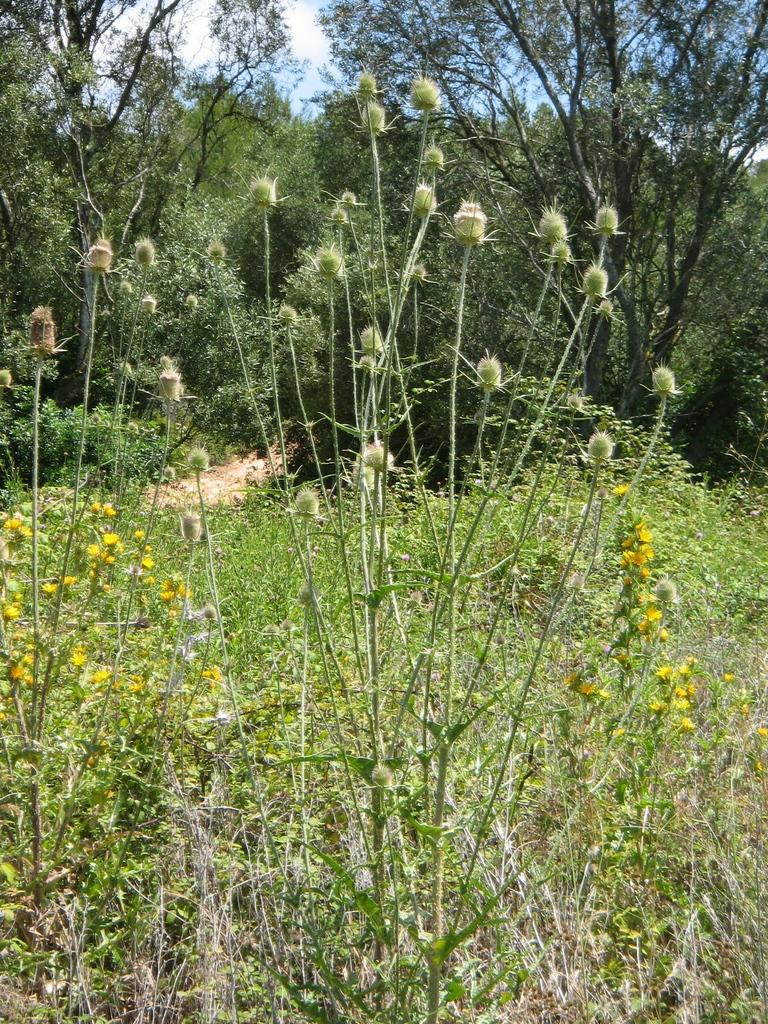What types of vegetation can be seen in the foreground of the picture? There are plants and flowers in the foreground of the picture. What elements are present in the center of the picture? There are trees and a path in the center of the picture. What can be seen in the background of the picture? There are trees and the sky visible in the background of the picture. How many bricks are visible in the picture? There are no bricks present in the image. What part of the plants and flowers is responsible for taking in carbon dioxide and releasing oxygen? The plants and flowers in the image do not have a specific part responsible for taking in carbon dioxide and releasing oxygen; this process occurs in the leaves through a process called photosynthesis. 